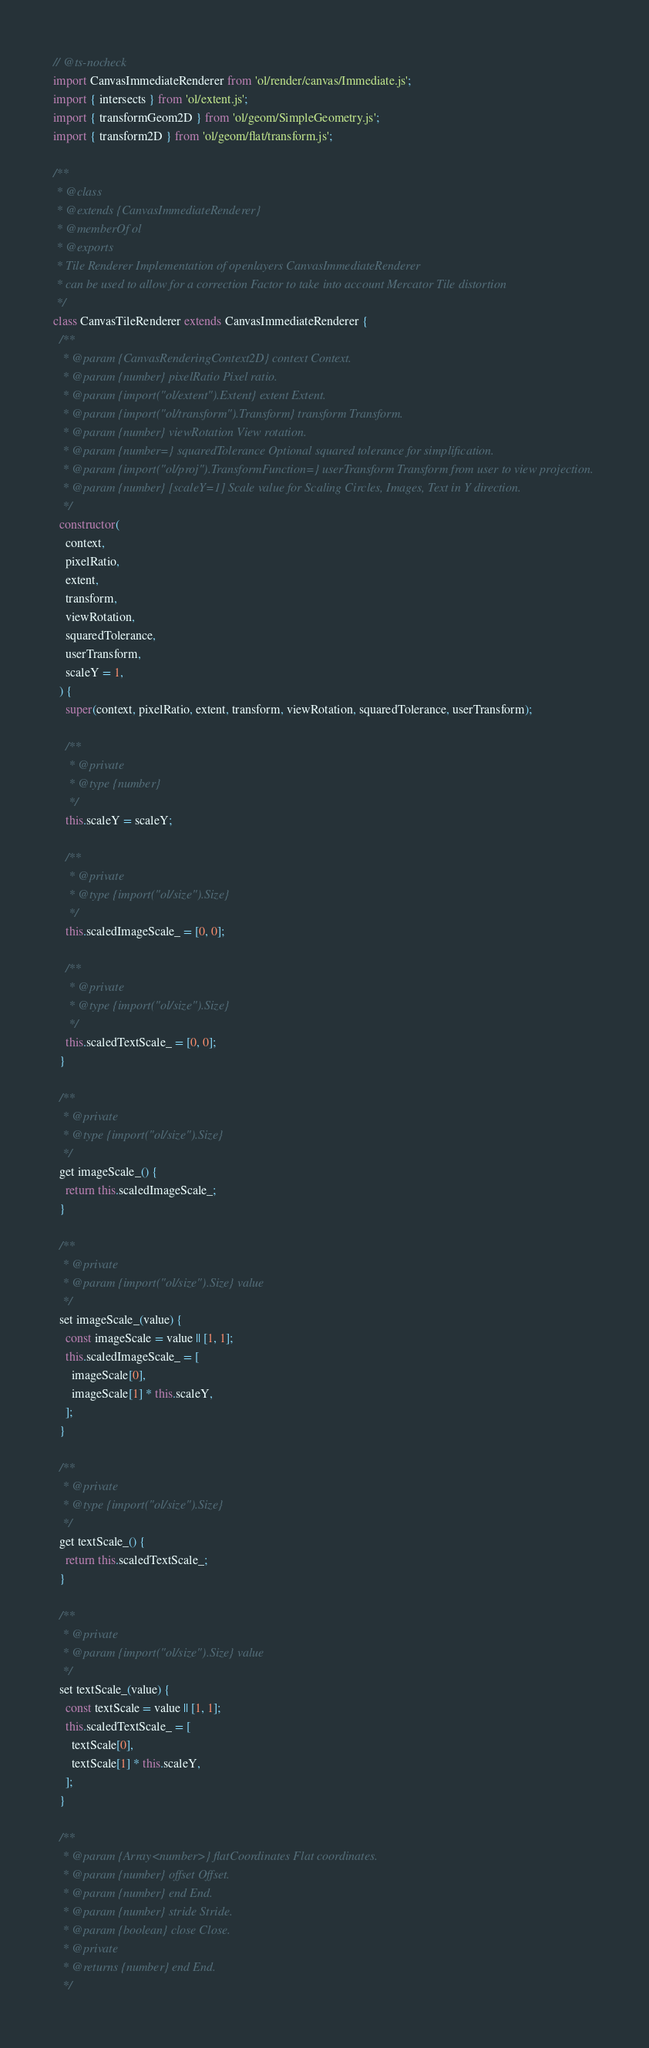<code> <loc_0><loc_0><loc_500><loc_500><_JavaScript_>// @ts-nocheck
import CanvasImmediateRenderer from 'ol/render/canvas/Immediate.js';
import { intersects } from 'ol/extent.js';
import { transformGeom2D } from 'ol/geom/SimpleGeometry.js';
import { transform2D } from 'ol/geom/flat/transform.js';

/**
 * @class
 * @extends {CanvasImmediateRenderer}
 * @memberOf ol
 * @exports
 * Tile Renderer Implementation of openlayers CanvasImmediateRenderer
 * can be used to allow for a correction Factor to take into account Mercator Tile distortion
 */
class CanvasTileRenderer extends CanvasImmediateRenderer {
  /**
   * @param {CanvasRenderingContext2D} context Context.
   * @param {number} pixelRatio Pixel ratio.
   * @param {import("ol/extent").Extent} extent Extent.
   * @param {import("ol/transform").Transform} transform Transform.
   * @param {number} viewRotation View rotation.
   * @param {number=} squaredTolerance Optional squared tolerance for simplification.
   * @param {import("ol/proj").TransformFunction=} userTransform Transform from user to view projection.
   * @param {number} [scaleY=1] Scale value for Scaling Circles, Images, Text in Y direction.
   */
  constructor(
    context,
    pixelRatio,
    extent,
    transform,
    viewRotation,
    squaredTolerance,
    userTransform,
    scaleY = 1,
  ) {
    super(context, pixelRatio, extent, transform, viewRotation, squaredTolerance, userTransform);

    /**
     * @private
     * @type {number}
     */
    this.scaleY = scaleY;

    /**
     * @private
     * @type {import("ol/size").Size}
     */
    this.scaledImageScale_ = [0, 0];

    /**
     * @private
     * @type {import("ol/size").Size}
     */
    this.scaledTextScale_ = [0, 0];
  }

  /**
   * @private
   * @type {import("ol/size").Size}
   */
  get imageScale_() {
    return this.scaledImageScale_;
  }

  /**
   * @private
   * @param {import("ol/size").Size} value
   */
  set imageScale_(value) {
    const imageScale = value || [1, 1];
    this.scaledImageScale_ = [
      imageScale[0],
      imageScale[1] * this.scaleY,
    ];
  }

  /**
   * @private
   * @type {import("ol/size").Size}
   */
  get textScale_() {
    return this.scaledTextScale_;
  }

  /**
   * @private
   * @param {import("ol/size").Size} value
   */
  set textScale_(value) {
    const textScale = value || [1, 1];
    this.scaledTextScale_ = [
      textScale[0],
      textScale[1] * this.scaleY,
    ];
  }

  /**
   * @param {Array<number>} flatCoordinates Flat coordinates.
   * @param {number} offset Offset.
   * @param {number} end End.
   * @param {number} stride Stride.
   * @param {boolean} close Close.
   * @private
   * @returns {number} end End.
   */</code> 